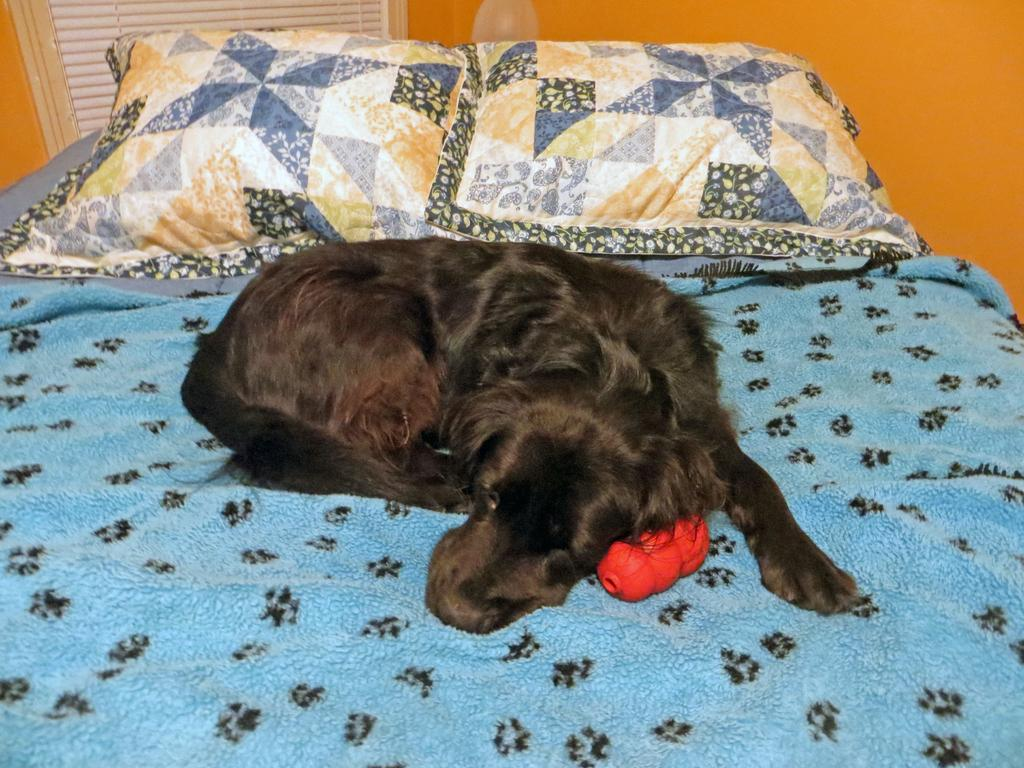What animal is on the bed in the image? There is a dog on the bed in the image. What type of furniture or accessory is present in the image? There is a pillow in the image. What can be seen in the background of the image? There is a wall in the image. What type of pain is the dog experiencing in the image? There is no indication in the image that the dog is experiencing any pain. 